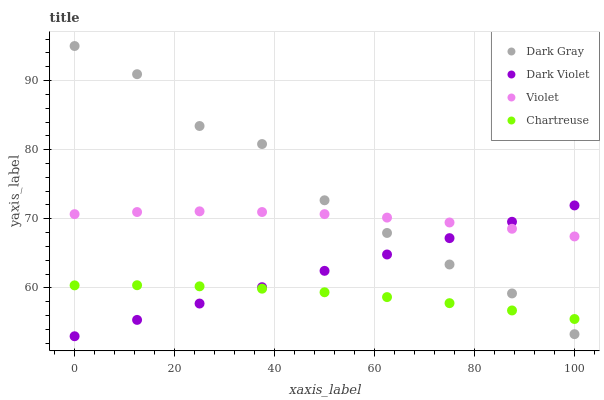Does Chartreuse have the minimum area under the curve?
Answer yes or no. Yes. Does Dark Gray have the maximum area under the curve?
Answer yes or no. Yes. Does Dark Violet have the minimum area under the curve?
Answer yes or no. No. Does Dark Violet have the maximum area under the curve?
Answer yes or no. No. Is Dark Violet the smoothest?
Answer yes or no. Yes. Is Dark Gray the roughest?
Answer yes or no. Yes. Is Chartreuse the smoothest?
Answer yes or no. No. Is Chartreuse the roughest?
Answer yes or no. No. Does Dark Violet have the lowest value?
Answer yes or no. Yes. Does Chartreuse have the lowest value?
Answer yes or no. No. Does Dark Gray have the highest value?
Answer yes or no. Yes. Does Dark Violet have the highest value?
Answer yes or no. No. Is Chartreuse less than Violet?
Answer yes or no. Yes. Is Violet greater than Chartreuse?
Answer yes or no. Yes. Does Dark Gray intersect Dark Violet?
Answer yes or no. Yes. Is Dark Gray less than Dark Violet?
Answer yes or no. No. Is Dark Gray greater than Dark Violet?
Answer yes or no. No. Does Chartreuse intersect Violet?
Answer yes or no. No. 